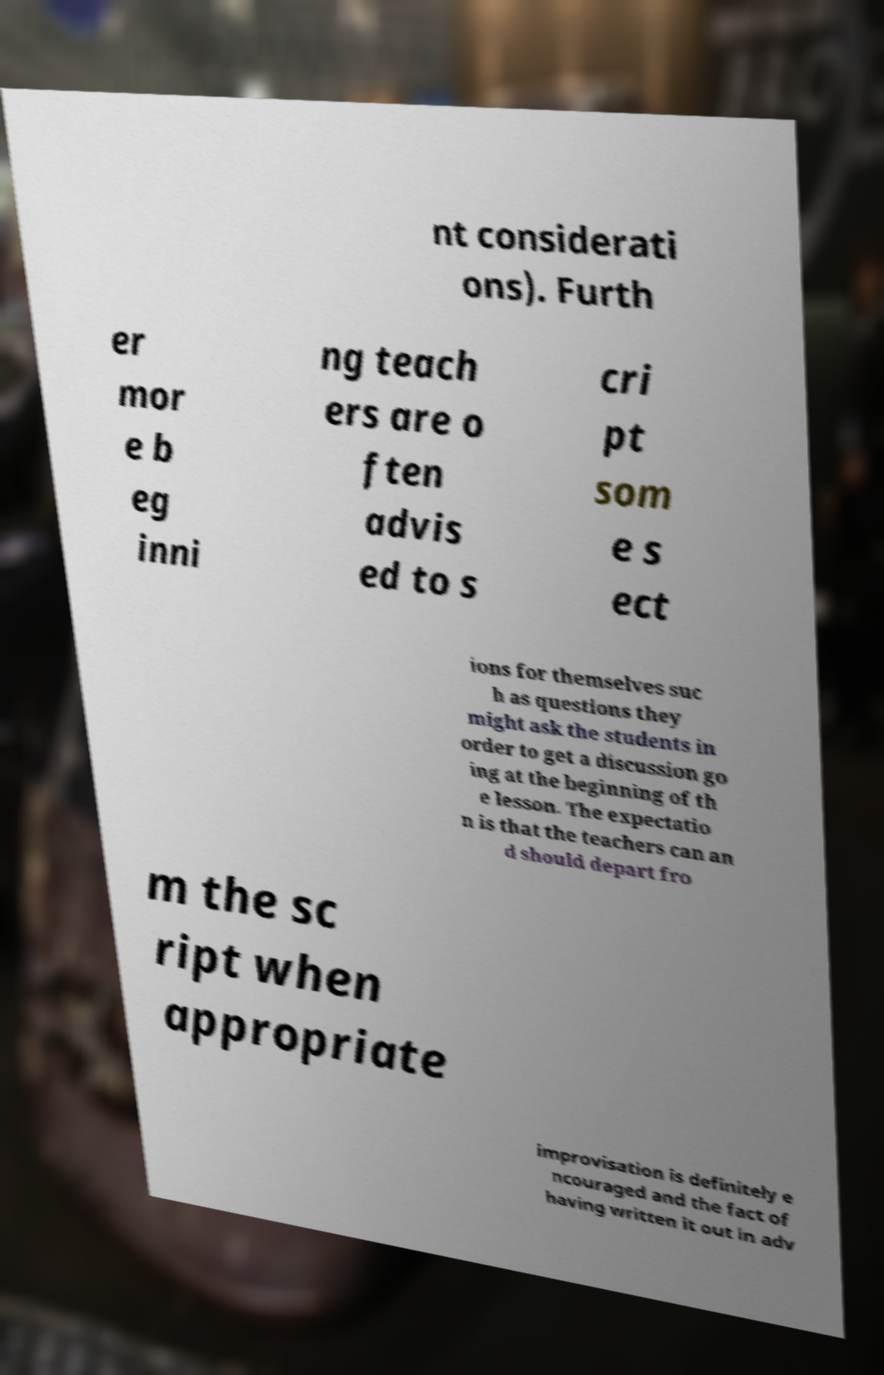For documentation purposes, I need the text within this image transcribed. Could you provide that? nt considerati ons). Furth er mor e b eg inni ng teach ers are o ften advis ed to s cri pt som e s ect ions for themselves suc h as questions they might ask the students in order to get a discussion go ing at the beginning of th e lesson. The expectatio n is that the teachers can an d should depart fro m the sc ript when appropriate improvisation is definitely e ncouraged and the fact of having written it out in adv 